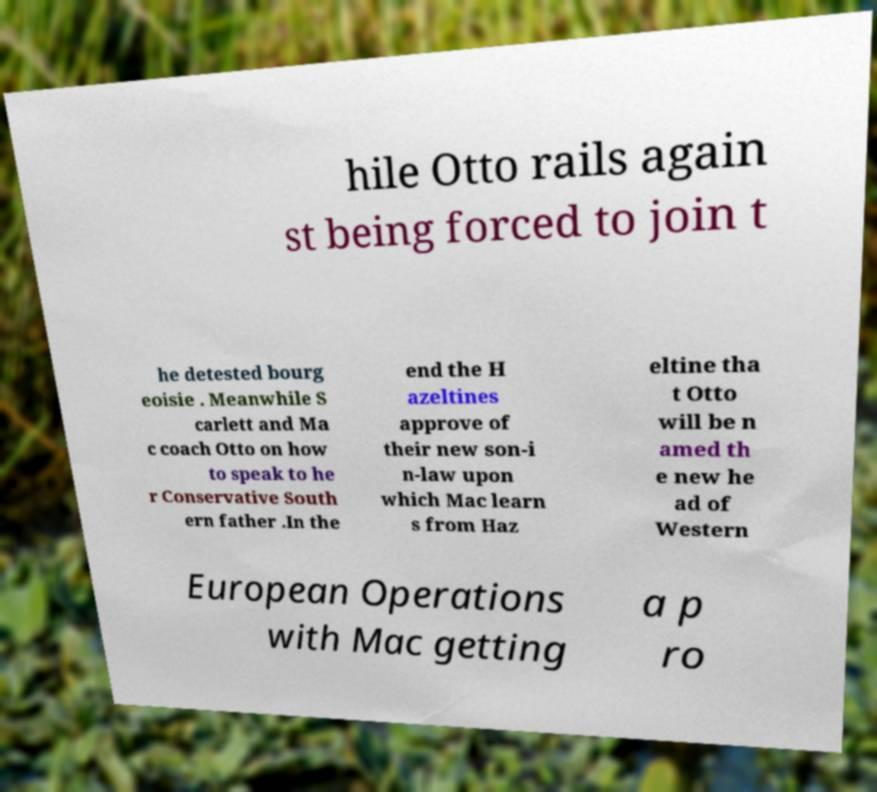Could you extract and type out the text from this image? hile Otto rails again st being forced to join t he detested bourg eoisie . Meanwhile S carlett and Ma c coach Otto on how to speak to he r Conservative South ern father .In the end the H azeltines approve of their new son-i n-law upon which Mac learn s from Haz eltine tha t Otto will be n amed th e new he ad of Western European Operations with Mac getting a p ro 